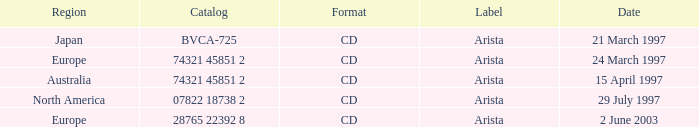What's the Date for the Region of Europe and has the Catalog of 28765 22392 8? 2 June 2003. 